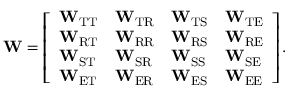<formula> <loc_0><loc_0><loc_500><loc_500>W = \left [ \begin{array} { l l l l } { W _ { T T } } & { W _ { T R } } & { W _ { T S } } & { W _ { T E } } \\ { W _ { R T } } & { W _ { R R } } & { W _ { R S } } & { W _ { R E } } \\ { W _ { S T } } & { W _ { S R } } & { W _ { S S } } & { W _ { S E } } \\ { W _ { E T } } & { W _ { E R } } & { W _ { E S } } & { W _ { E E } } \end{array} \right ] .</formula> 